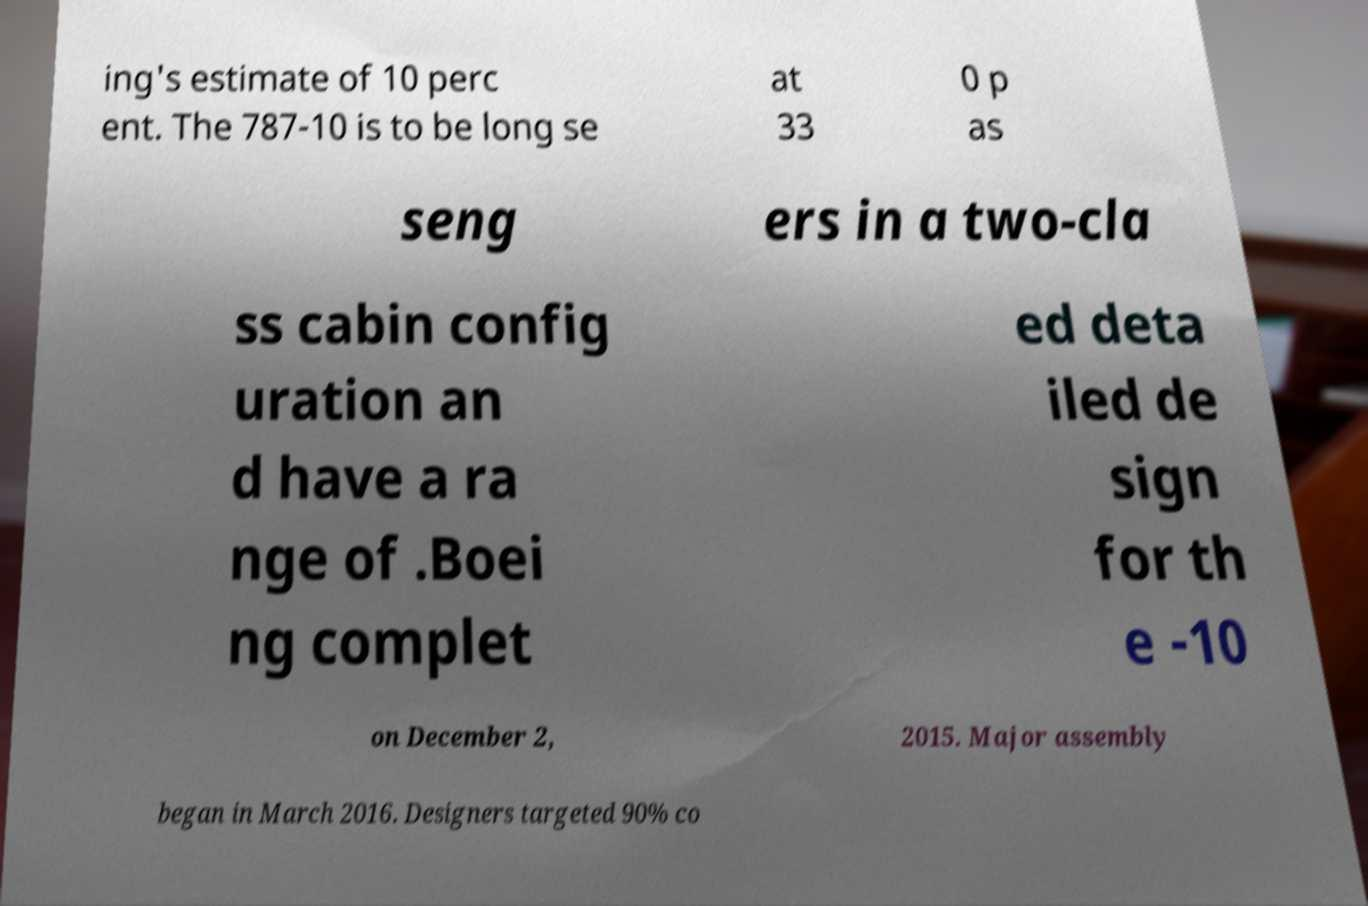I need the written content from this picture converted into text. Can you do that? ing's estimate of 10 perc ent. The 787-10 is to be long se at 33 0 p as seng ers in a two-cla ss cabin config uration an d have a ra nge of .Boei ng complet ed deta iled de sign for th e -10 on December 2, 2015. Major assembly began in March 2016. Designers targeted 90% co 